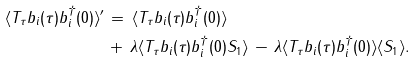Convert formula to latex. <formula><loc_0><loc_0><loc_500><loc_500>\, \langle T _ { \tau } b _ { i } ( \tau ) b _ { i } ^ { \dagger } ( 0 ) \rangle ^ { \prime } \, & = \, \langle T _ { \tau } b _ { i } ( \tau ) b _ { i } ^ { \dagger } ( 0 ) \rangle \, \\ & + \, \lambda \langle T _ { \tau } b _ { i } ( \tau ) b _ { i } ^ { \dagger } ( 0 ) S _ { 1 } \rangle \, - \, \lambda \langle T _ { \tau } b _ { i } ( \tau ) b _ { i } ^ { \dagger } ( 0 ) \rangle \langle S _ { 1 } \rangle .</formula> 